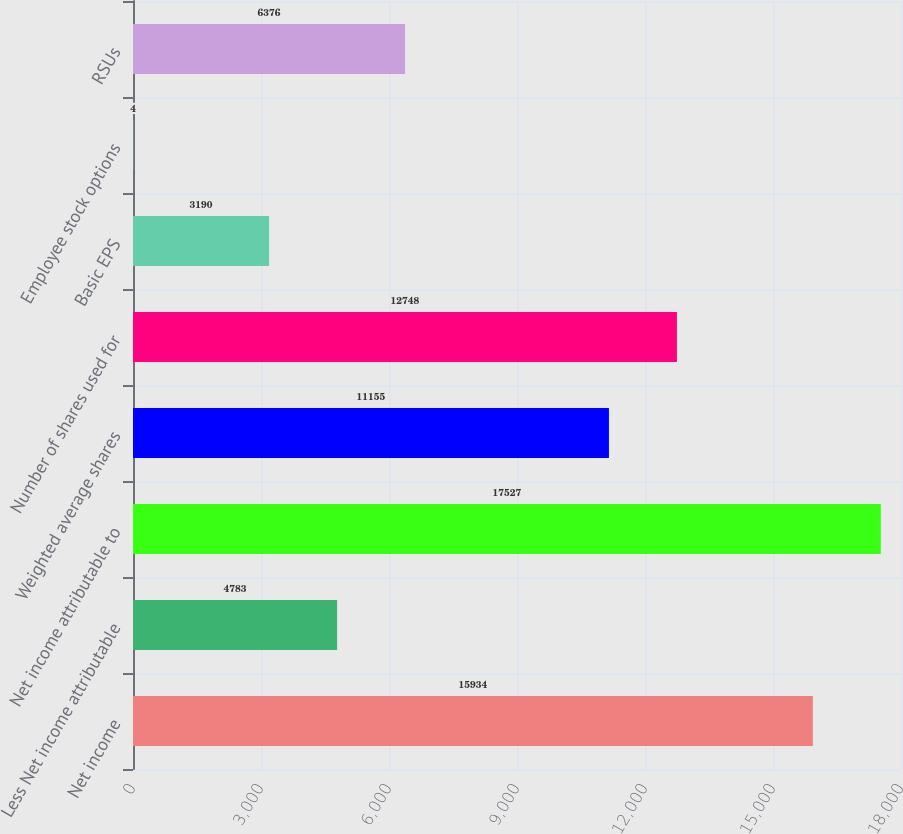Convert chart. <chart><loc_0><loc_0><loc_500><loc_500><bar_chart><fcel>Net income<fcel>Less Net income attributable<fcel>Net income attributable to<fcel>Weighted average shares<fcel>Number of shares used for<fcel>Basic EPS<fcel>Employee stock options<fcel>RSUs<nl><fcel>15934<fcel>4783<fcel>17527<fcel>11155<fcel>12748<fcel>3190<fcel>4<fcel>6376<nl></chart> 